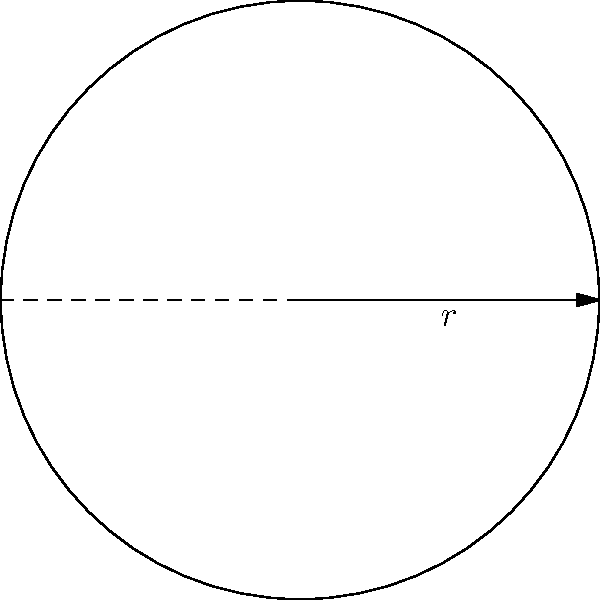As amateur historians deciphering ancient cylindrical seal impressions, you've come across a particularly intriguing specimen. The circumference of the seal impression measures 12.56 cm. Using the relationship between circumference and radius in circle geometry, calculate the radius of this cylindrical seal to the nearest millimeter. Let's approach this step-by-step:

1) We know that the circumference of a circle is related to its radius by the formula:

   $C = 2\pi r$

   Where $C$ is the circumference and $r$ is the radius.

2) We're given that the circumference $C = 12.56$ cm.

3) Let's substitute this into our formula:

   $12.56 = 2\pi r$

4) To solve for $r$, we need to divide both sides by $2\pi$:

   $\frac{12.56}{2\pi} = r$

5) Let's calculate this:

   $r = \frac{12.56}{2\pi} \approx 1.9999$ cm

6) Rounding to the nearest millimeter (0.1 cm):

   $r \approx 2.0$ cm

Therefore, the radius of the cylindrical seal is approximately 2.0 cm or 20 mm.
Answer: 2.0 cm 